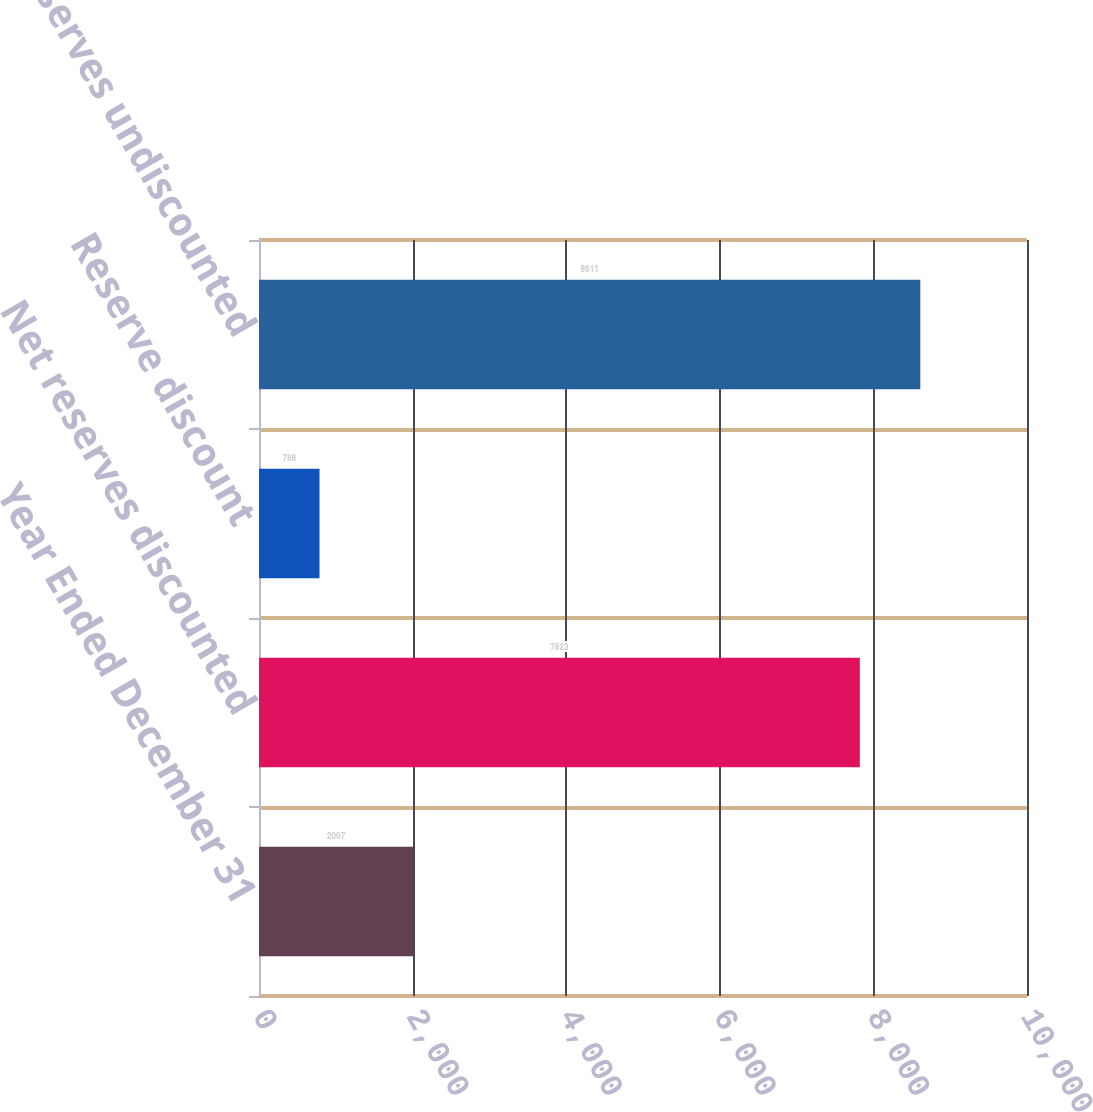Convert chart. <chart><loc_0><loc_0><loc_500><loc_500><bar_chart><fcel>Year Ended December 31<fcel>Net reserves discounted<fcel>Reserve discount<fcel>Net reserves undiscounted<nl><fcel>2007<fcel>7823<fcel>788<fcel>8611<nl></chart> 